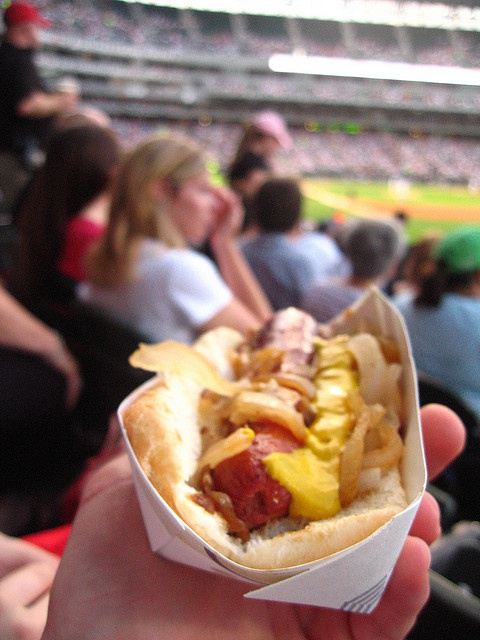Describe the objects in this image and their specific colors. I can see hot dog in gray, tan, red, and ivory tones, people in gray, maroon, and brown tones, people in gray, brown, maroon, and lavender tones, people in gray, black, brown, and maroon tones, and people in gray, black, maroon, and brown tones in this image. 